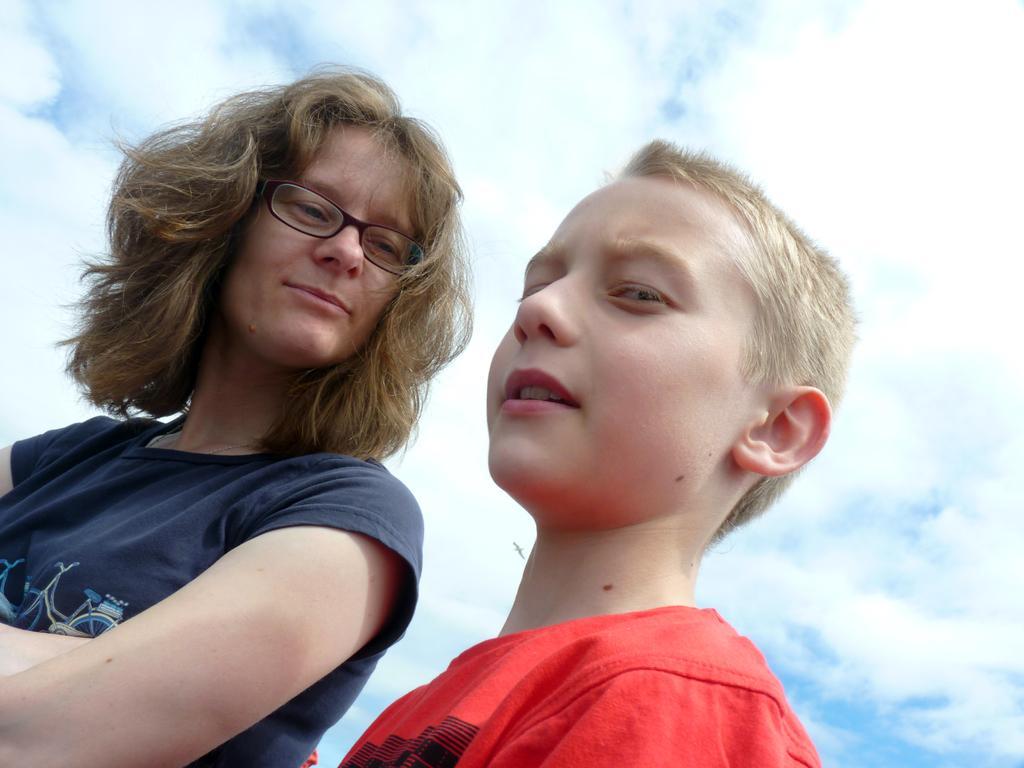Describe this image in one or two sentences. This picture is clicked outside. In the foreground we can see the two people wearing t-shirts and seems to be standing. In the background we can see the sky with the clouds. 